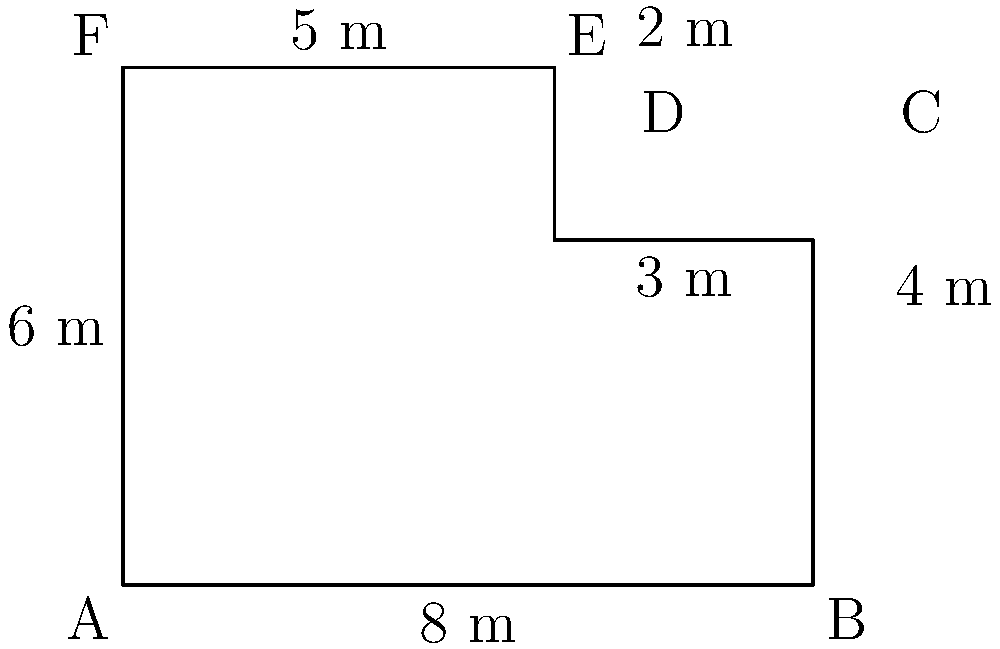As a successful business owner, you're looking to expand your operations by purchasing a new plot of land. The land has an irregular shape, as shown in the diagram. Calculate the perimeter of this plot to determine the fencing costs. All measurements are in meters. To calculate the perimeter of the irregular plot, we need to sum up the lengths of all sides:

1. Side AB: $8$ m
2. Side BC: $4$ m
3. Side CD: $3$ m
4. Side DE: $2$ m
5. Side EF: $5$ m
6. Side FA: $6$ m

Now, let's add all these lengths:

$$\text{Perimeter} = 8 + 4 + 3 + 2 + 5 + 6 = 28$$

Therefore, the perimeter of the plot is 28 meters.
Answer: 28 m 